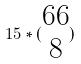Convert formula to latex. <formula><loc_0><loc_0><loc_500><loc_500>1 5 * ( \begin{matrix} 6 6 \\ 8 \end{matrix} )</formula> 